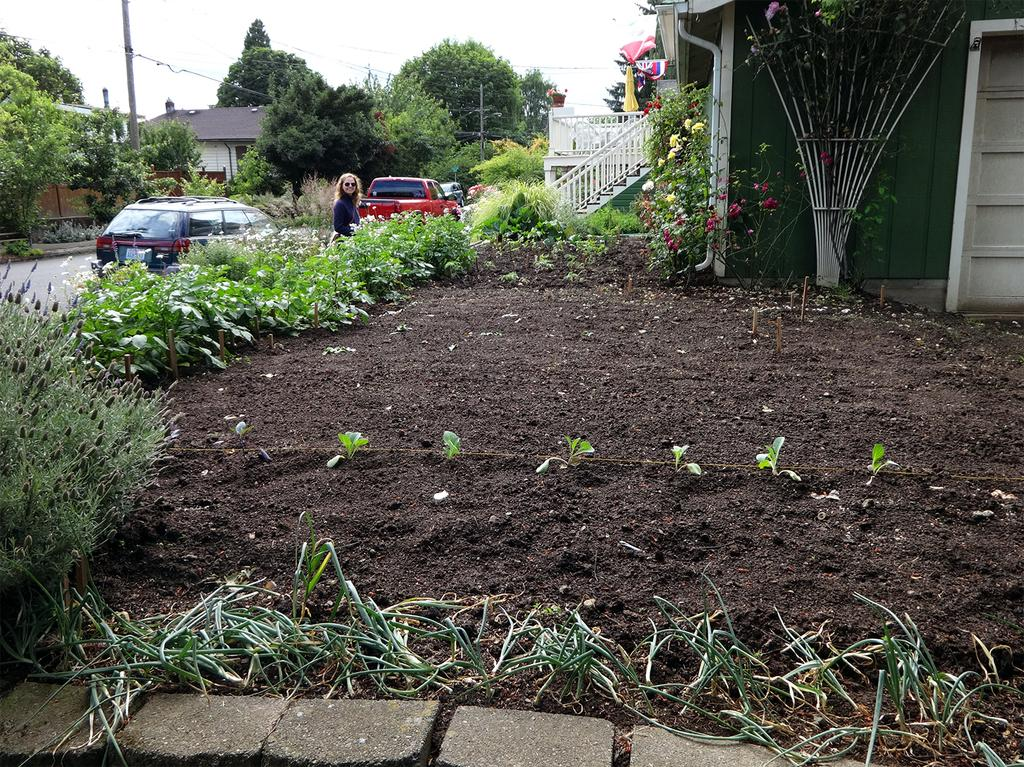What is the main feature in the center of the image? There is a sky in the center of the image. What types of structures can be seen in the image? There are buildings in the image. What natural elements are present in the image? There are trees and plants in the image. What man-made structures can be seen in the image? There are fences in the image. What mode of transportation is visible in the image? There are vehicles in the image. What type of flora can be seen in the image? There are flowers in the image. What vertical structure is present in the image? There is a pole in the image. Can you describe the person in the image? There is a person standing in the image, and they are wearing glasses. What other objects can be seen in the image? There are a few other objects in the image. What type of operation is being performed on the wool in the image? There is no wool or operation present in the image. 